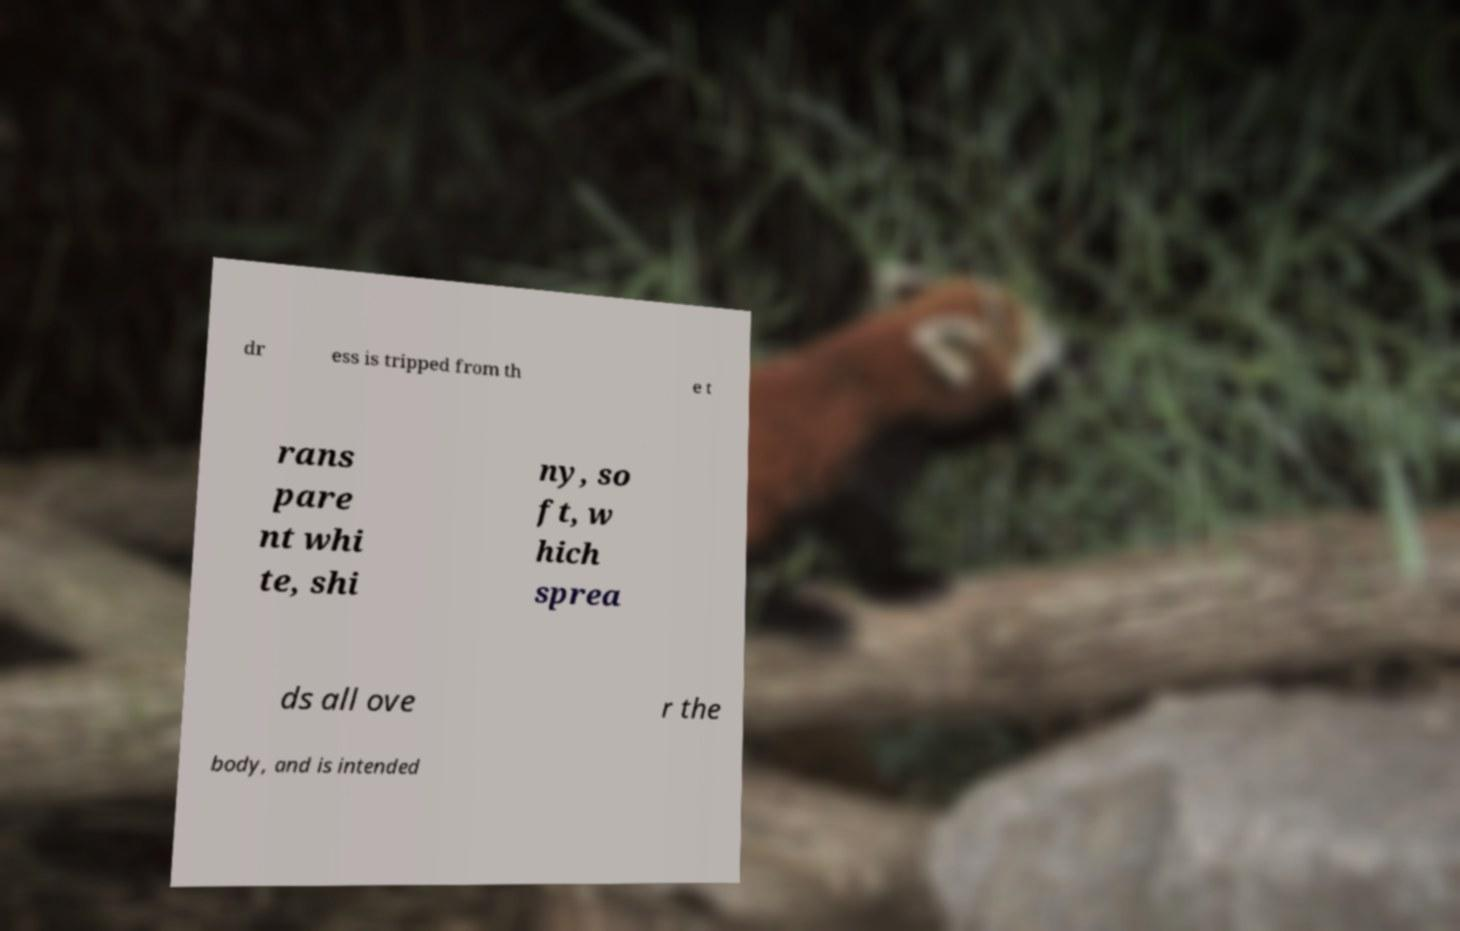Please identify and transcribe the text found in this image. dr ess is tripped from th e t rans pare nt whi te, shi ny, so ft, w hich sprea ds all ove r the body, and is intended 